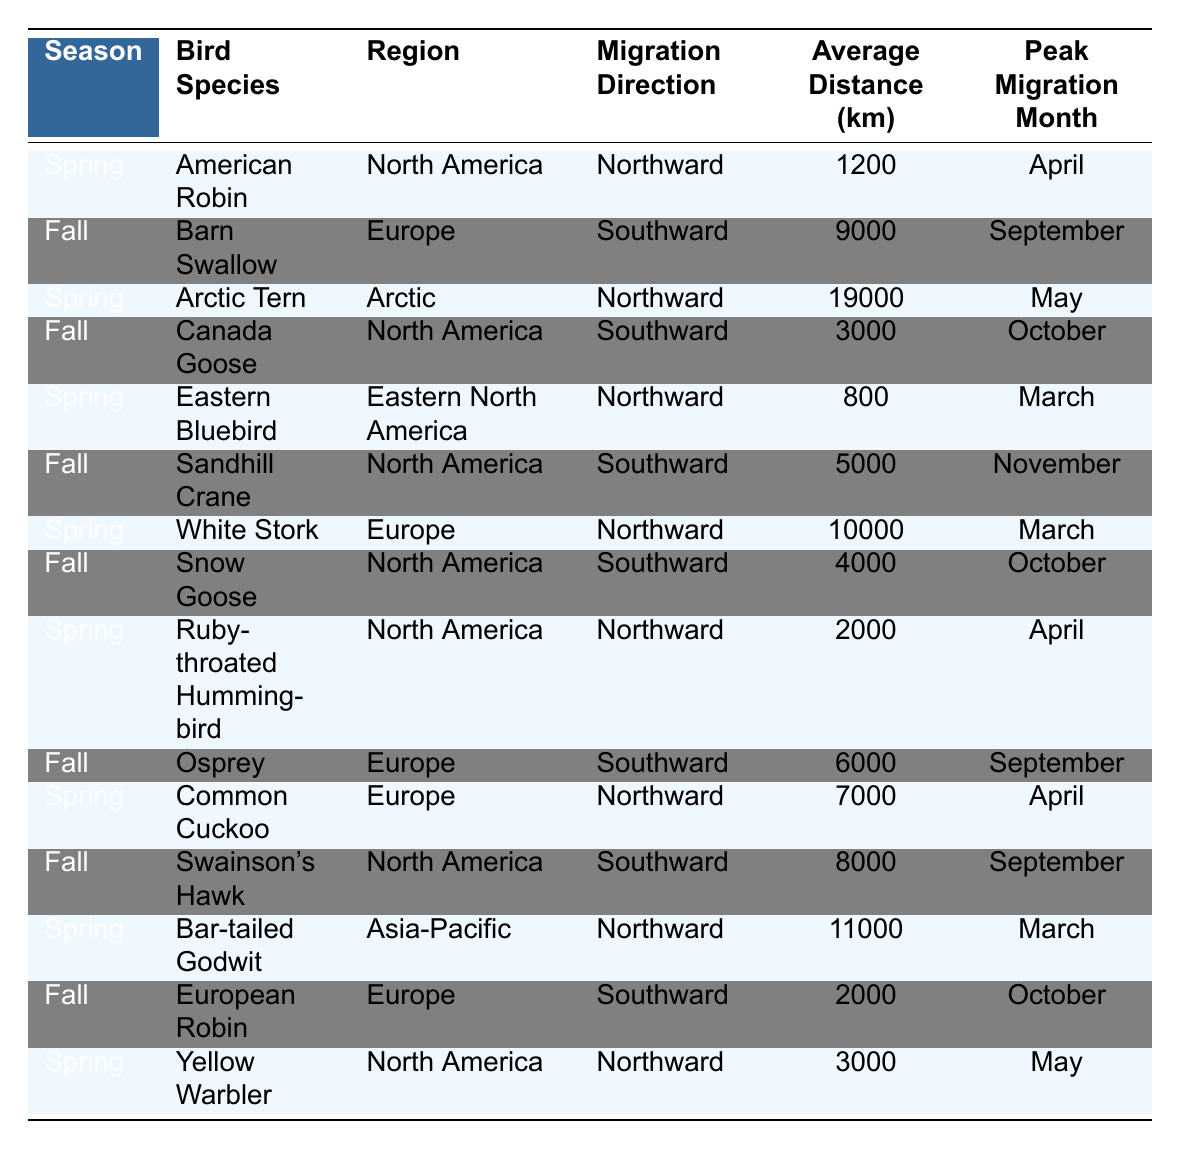What is the average migration distance for the American Robin? The average distance for the American Robin is explicitly listed in the table as 1200 km.
Answer: 1200 km What month do the Barn Swallows peak their migration? The peak migration month for Barn Swallows is stated in the table as September.
Answer: September How many bird species migrate northward in spring? By counting the entries under the Spring season and the Migration Direction labeled as Northward, we find there are 7 such bird species in the table.
Answer: 7 Is the average migration distance for the Arctic Tern longer than 15,000 km? The table indicates that the Arctic Tern migrates an average distance of 19,000 km, which is longer than 15,000 km.
Answer: Yes What is the total average migration distance for the birds migrating southward in fall? The average distances for the southward migrating birds in fall are: Barn Swallow (9000), Canada Goose (3000), Sandhill Crane (5000), Snow Goose (4000), Osprey (6000), Swainson's Hawk (8000), and European Robin (2000). The total is 9000 + 3000 + 5000 + 4000 + 6000 + 8000 + 2000 = 36,000 km. The average distance then is 36,000 / 7 ≈ 5143 km.
Answer: 5143 km Which region has the highest number of migrating species listed? The table indicates that North America has multiple entries: American Robin, Canada Goose, Eastern Bluebird, Sandhill Crane, Snow Goose, Swainson's Hawk, and Yellow Warbler, totaling 7 species. In comparison, Europe has 5 species, and Arctic and Asia-Pacific each have 1. North America has the highest count.
Answer: North America How many different species migrate in March? Looking at the table, the following species are listed for March: Eastern Bluebird, White Stork, and Bar-tailed Godwit, totaling 3 different species.
Answer: 3 Which species migrates the greatest average distance? The table shows that the Arctic Tern has the highest average migration distance at 19,000 km.
Answer: Arctic Tern Is it true that the average distance for the birds migrating in spring exceeds 10,000 km? The distances for spring migrations are: American Robin (1200), Arctic Tern (19000), Eastern Bluebird (800), White Stork (10000), Ruby-throated Hummingbird (2000), Common Cuckoo (7000), Bar-tailed Godwit (11000), and Yellow Warbler (3000). The total is 77,000 km and the average is 77,000 / 8 = 9625 km, which does not exceed 10,000 km.
Answer: No How does the peak migration month for the Canada Goose compare to the Snow Goose? The peak migration month for Canada Goose is October and for Snow Goose it is also October. Thus, both have the same peak month.
Answer: Same month: October What is the difference in average migration distance between the longest and shortest migrating species listed? The longest migrating species is the Arctic Tern at 19,000 km and the shortest is the Eastern Bluebird at 800 km. The difference is 19000 - 800 = 18200 km.
Answer: 18200 km 